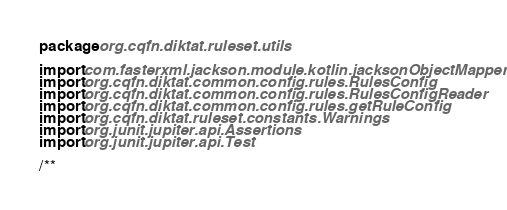Convert code to text. <code><loc_0><loc_0><loc_500><loc_500><_Kotlin_>package org.cqfn.diktat.ruleset.utils

import com.fasterxml.jackson.module.kotlin.jacksonObjectMapper
import org.cqfn.diktat.common.config.rules.RulesConfig
import org.cqfn.diktat.common.config.rules.RulesConfigReader
import org.cqfn.diktat.common.config.rules.getRuleConfig
import org.cqfn.diktat.ruleset.constants.Warnings
import org.junit.jupiter.api.Assertions
import org.junit.jupiter.api.Test

/**</code> 